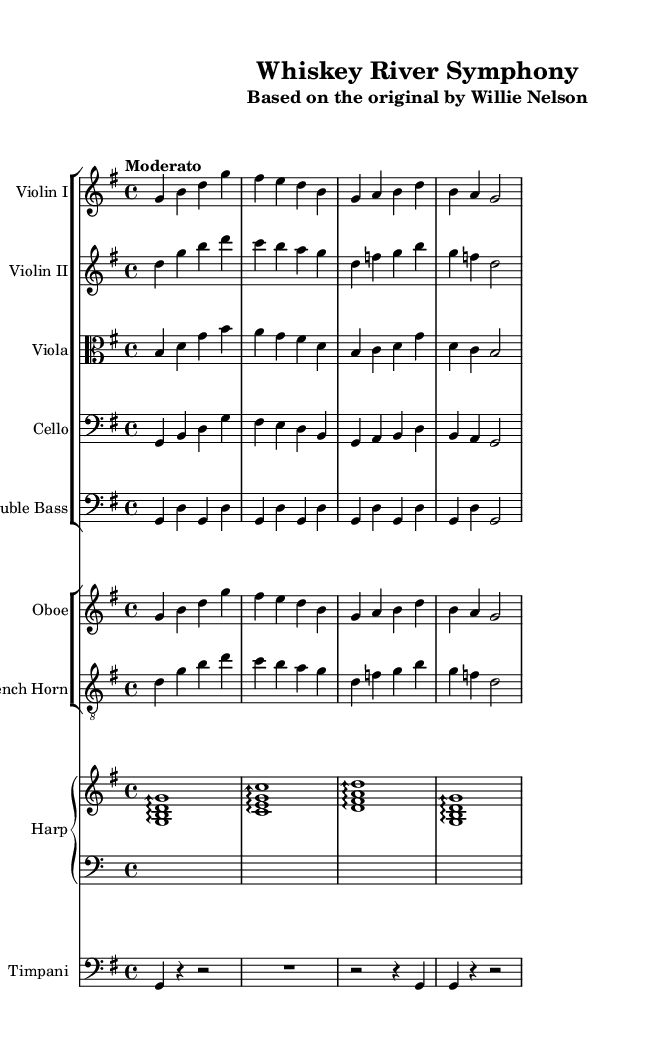What is the key signature of this music? The key signature is G major, which has one sharp (F#). This can be identified from the key signature notation at the beginning of the score.
Answer: G major What is the time signature of the piece? The time signature is 4/4, meaning there are four beats in each measure and the quarter note receives one beat. This is seen in the fraction notation at the beginning of the score.
Answer: 4/4 What is the tempo of the piece? The tempo is marked as "Moderato," indicating a moderately paced tempo for the performance. This is labeled at the beginning of the score after the time signature.
Answer: Moderato How many measures are in the score? By visually counting the measures in the respective staves, there are 8 measures in total throughout the composition, as indicated by the bar lines.
Answer: 8 Which instruments are featured in this arrangement? The arrangement features a Violin I, Violin II, Viola, Cello, Double Bass, Oboe, French Horn, Harp, and Timpani. These instruments are listed at the beginning of each staff in the score.
Answer: Violin I, Violin II, Viola, Cello, Double Bass, Oboe, French Horn, Harp, Timpani What is the primary melodic instrument in this arrangement? The primary melodic interest in orchestral arrangements of classic country tunes often falls on the Violins, particularly Violin I in this score, which plays the main theme. This can be inferred through its prominent part at the start of the piece.
Answer: Violin I 